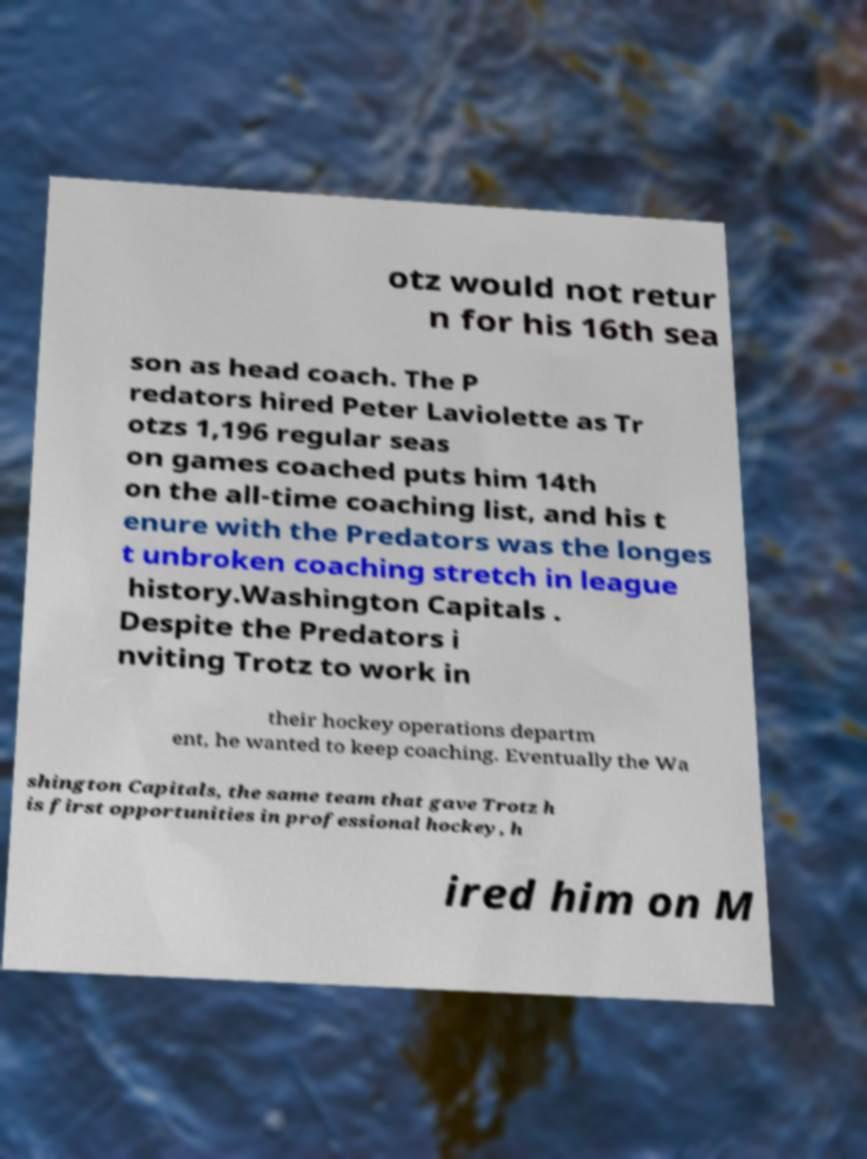There's text embedded in this image that I need extracted. Can you transcribe it verbatim? otz would not retur n for his 16th sea son as head coach. The P redators hired Peter Laviolette as Tr otzs 1,196 regular seas on games coached puts him 14th on the all-time coaching list, and his t enure with the Predators was the longes t unbroken coaching stretch in league history.Washington Capitals . Despite the Predators i nviting Trotz to work in their hockey operations departm ent, he wanted to keep coaching. Eventually the Wa shington Capitals, the same team that gave Trotz h is first opportunities in professional hockey, h ired him on M 